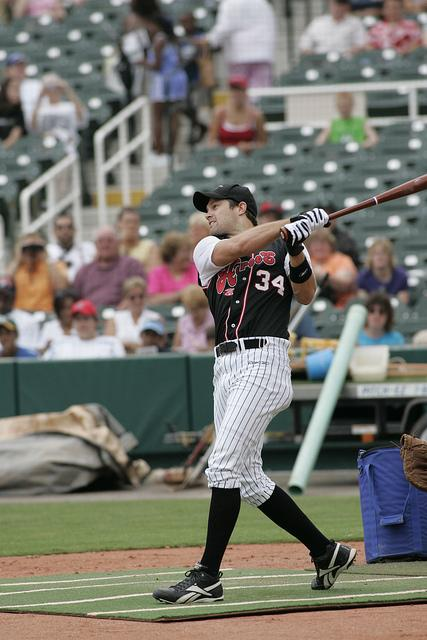Why is the player wearing gloves? grip bat 